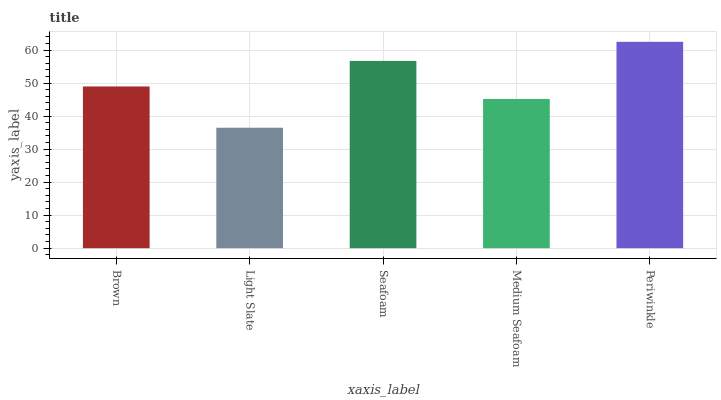Is Light Slate the minimum?
Answer yes or no. Yes. Is Periwinkle the maximum?
Answer yes or no. Yes. Is Seafoam the minimum?
Answer yes or no. No. Is Seafoam the maximum?
Answer yes or no. No. Is Seafoam greater than Light Slate?
Answer yes or no. Yes. Is Light Slate less than Seafoam?
Answer yes or no. Yes. Is Light Slate greater than Seafoam?
Answer yes or no. No. Is Seafoam less than Light Slate?
Answer yes or no. No. Is Brown the high median?
Answer yes or no. Yes. Is Brown the low median?
Answer yes or no. Yes. Is Seafoam the high median?
Answer yes or no. No. Is Light Slate the low median?
Answer yes or no. No. 